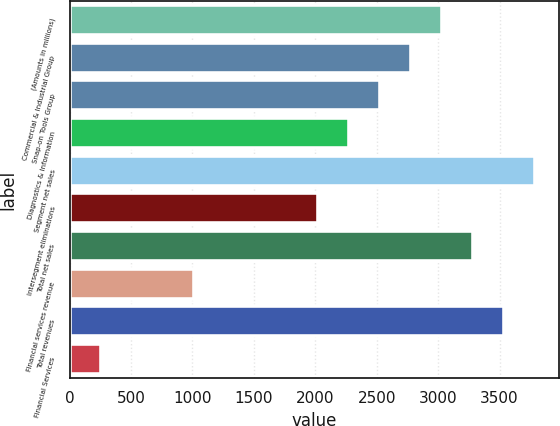Convert chart. <chart><loc_0><loc_0><loc_500><loc_500><bar_chart><fcel>(Amounts in millions)<fcel>Commercial & Industrial Group<fcel>Snap-on Tools Group<fcel>Diagnostics & Information<fcel>Segment net sales<fcel>Intersegment eliminations<fcel>Total net sales<fcel>Financial services revenue<fcel>Total revenues<fcel>Financial Services<nl><fcel>3033.94<fcel>2781.37<fcel>2528.8<fcel>2276.23<fcel>3791.65<fcel>2023.66<fcel>3286.51<fcel>1013.38<fcel>3539.08<fcel>255.67<nl></chart> 